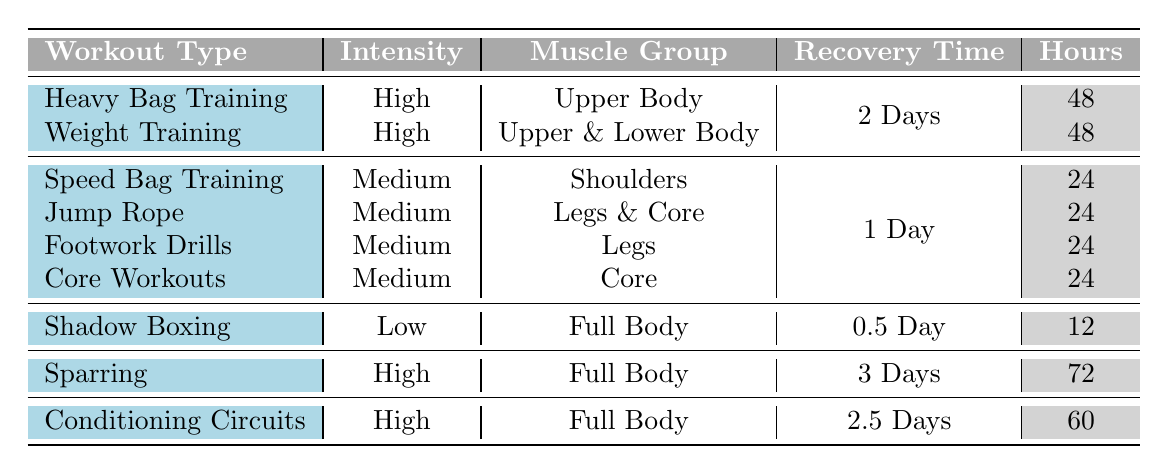What is the recovery time for Heavy Bag Training? The table shows that the recovery time for Heavy Bag Training is listed as 48 hours.
Answer: 48 hours Which workout has the shortest recovery time? According to the table, Shadow Boxing has a recovery time of 12 hours, which is the shortest compared to all other workouts listed.
Answer: Shadow Boxing Is the recovery time for Medium intensity workouts the same for all muscle groups? The table indicates that all Medium intensity workouts, including Speed Bag Training, Jump Rope, Footwork Drills, and Core Workouts, have the same recovery time of 24 hours, confirming they are equal.
Answer: Yes How much longer is the recovery time for Sparring compared to Shadow Boxing? Sparring has a recovery time of 72 hours and Shadow Boxing has 12 hours. The difference is calculated as 72 - 12 = 60 hours, meaning the recovery time for Sparring is 60 hours longer.
Answer: 60 hours How many workouts require 48 hours of recovery time? The table features two workouts, Heavy Bag Training and Weight Training, both of which require a recovery time of 48 hours. Therefore, the total is 2.
Answer: 2 What is the average recovery time of High intensity workouts? The table shows two High intensity workouts: Heavy Bag Training and Weight Training, both with 48 hours, and Conditioning Circuits with 60 hours. Calculating the average: (48 + 48 + 60) / 3 = 52 hours.
Answer: 52 hours Is there any workout that requires more than 2 days of recovery time? The table lists Sparring with a recovery time of 72 hours (3 days) and Conditioning Circuits with 60 hours (2.5 days), which are both greater than 2 days.
Answer: Yes What muscle groups are targeted by workouts that require 24 hours of recovery time? The table shows that Speed Bag Training, Jump Rope, Footwork Drills, and Core Workouts all target different muscle groups (Shoulders, Legs & Core, Legs, and Core respectively), confirming that multiple groups are targeted.
Answer: Shoulders, Legs & Core, Legs, Core 